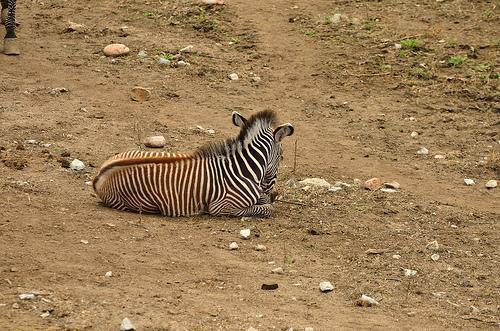How many animals can be seen in the photo?
Give a very brief answer. 2. How many zebras are laying down?
Give a very brief answer. 1. How many people appear in the photo?
Give a very brief answer. 0. How many Zebras are shown?
Give a very brief answer. 1. 